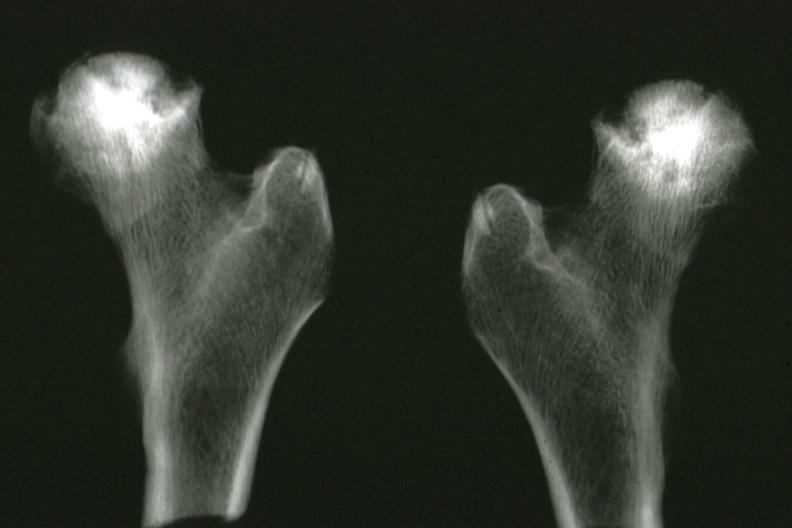s x-ray of femoral heads removed at autopsy good illustration?
Answer the question using a single word or phrase. Yes 